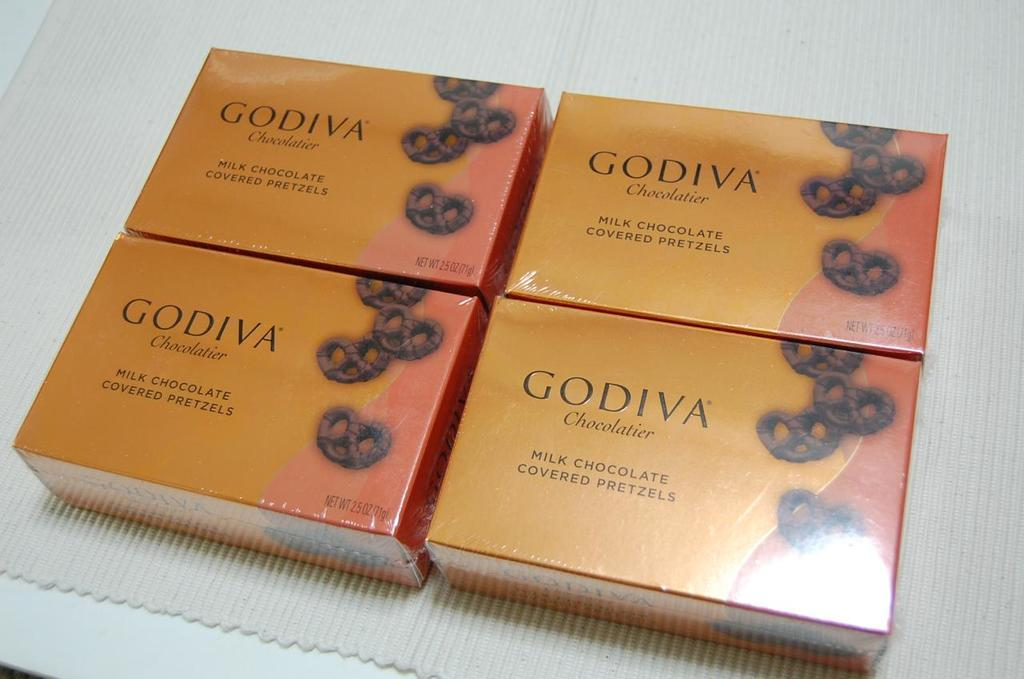Provide a one-sentence caption for the provided image. Four Godiva boxes of chocolate sat on top of the table. 